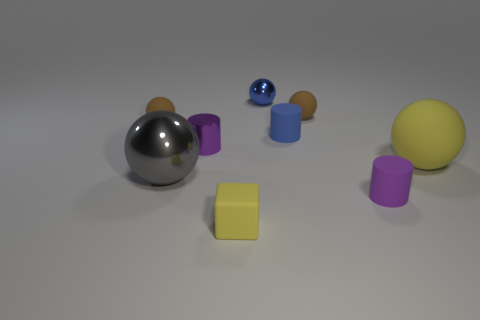Subtract all blue spheres. How many spheres are left? 4 Subtract all brown balls. How many balls are left? 3 Subtract all blue cubes. How many brown balls are left? 2 Subtract 1 cylinders. How many cylinders are left? 2 Subtract all balls. How many objects are left? 4 Subtract all rubber spheres. Subtract all small purple objects. How many objects are left? 4 Add 3 small yellow rubber objects. How many small yellow rubber objects are left? 4 Add 7 tiny brown rubber cylinders. How many tiny brown rubber cylinders exist? 7 Subtract 0 brown cubes. How many objects are left? 9 Subtract all red spheres. Subtract all purple cubes. How many spheres are left? 5 